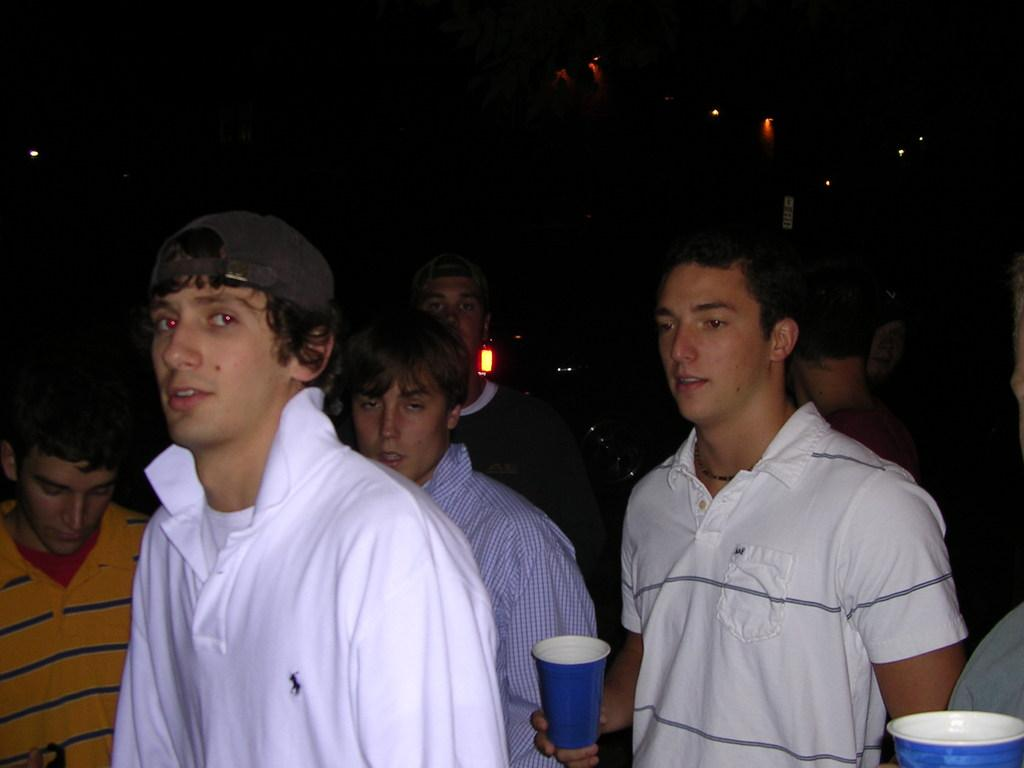What is the main focus of the image? The main focus of the image is the people in the center. What are some of the people doing in the image? Some of the people are holding glasses in their hands. What can be seen in the background of the image? There are lights in the background of the image. What type of vest is the expert wearing in the image? There is no expert or vest present in the image. What type of alley can be seen in the background of the image? There is no alley present in the image; only lights can be seen in the background. 